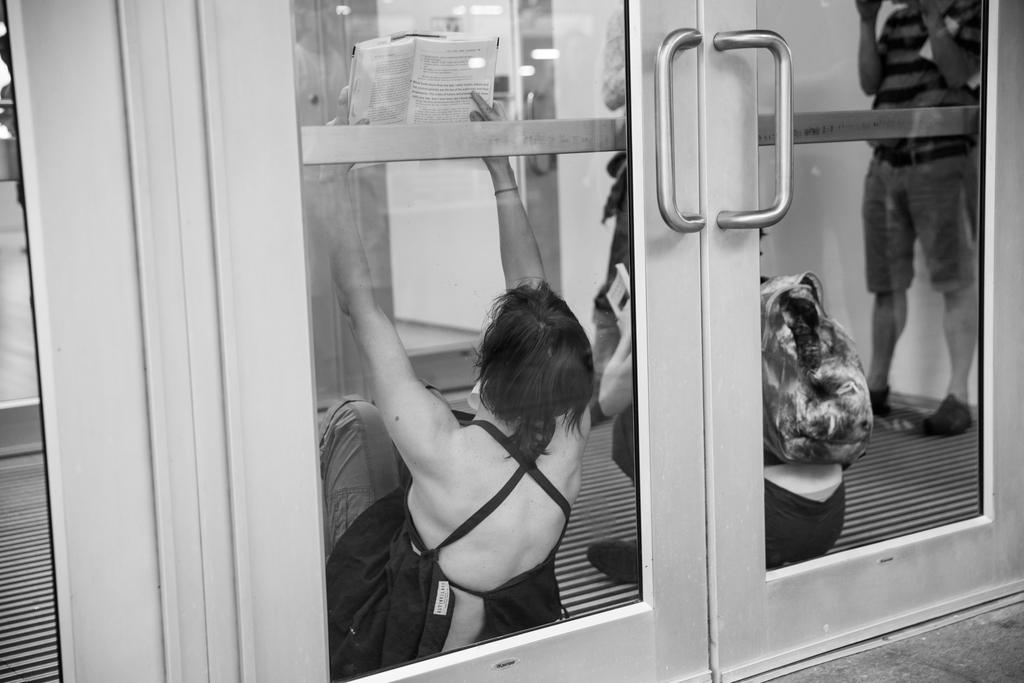What type of doors are shown in the image? There are glass doors in the image. What can be seen through the glass doors? People are visible through the glass doors. What is the woman holding in the image? The woman is holding a book. How many cars are parked outside the glass doors in the image? There is no information about cars in the image; it only shows glass doors and people visible through them. 